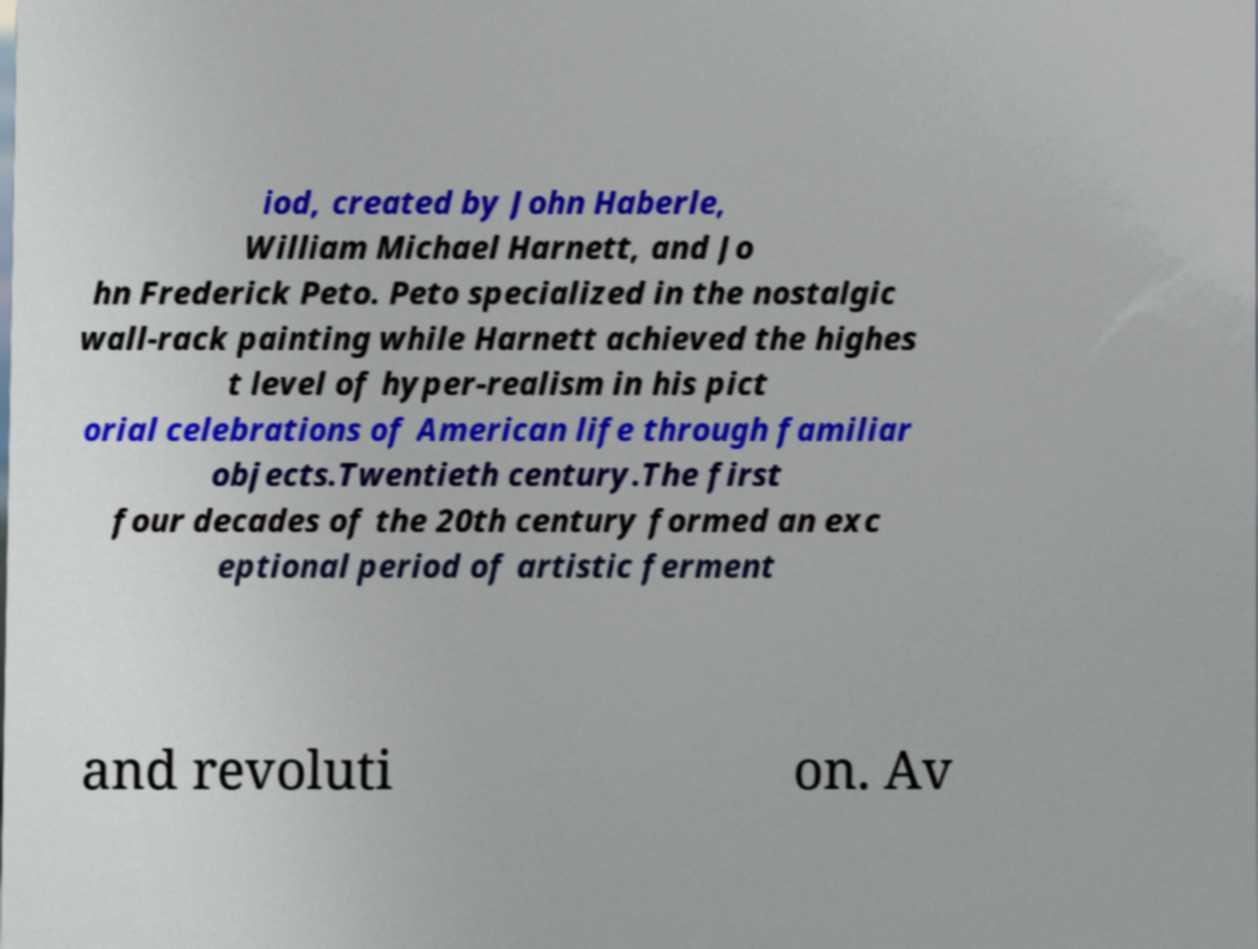Please identify and transcribe the text found in this image. iod, created by John Haberle, William Michael Harnett, and Jo hn Frederick Peto. Peto specialized in the nostalgic wall-rack painting while Harnett achieved the highes t level of hyper-realism in his pict orial celebrations of American life through familiar objects.Twentieth century.The first four decades of the 20th century formed an exc eptional period of artistic ferment and revoluti on. Av 